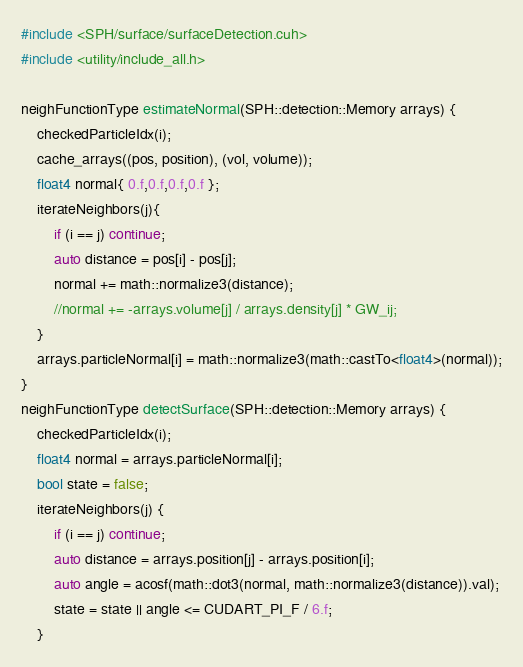Convert code to text. <code><loc_0><loc_0><loc_500><loc_500><_Cuda_>#include <SPH/surface/surfaceDetection.cuh>
#include <utility/include_all.h>

neighFunctionType estimateNormal(SPH::detection::Memory arrays) {
	checkedParticleIdx(i);
	cache_arrays((pos, position), (vol, volume));
	float4 normal{ 0.f,0.f,0.f,0.f };
	iterateNeighbors(j){
		if (i == j) continue;
		auto distance = pos[i] - pos[j];
		normal += math::normalize3(distance);
		//normal += -arrays.volume[j] / arrays.density[j] * GW_ij;
	}
	arrays.particleNormal[i] = math::normalize3(math::castTo<float4>(normal));
}
neighFunctionType detectSurface(SPH::detection::Memory arrays) {
	checkedParticleIdx(i);
	float4 normal = arrays.particleNormal[i];
	bool state = false;
	iterateNeighbors(j) {
		if (i == j) continue;
		auto distance = arrays.position[j] - arrays.position[i];
		auto angle = acosf(math::dot3(normal, math::normalize3(distance)).val);
		state = state || angle <= CUDART_PI_F / 6.f;
	}
</code> 